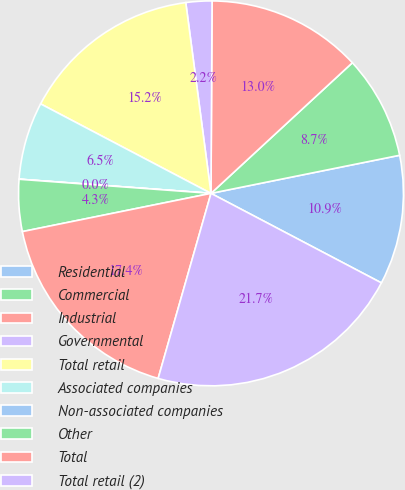Convert chart. <chart><loc_0><loc_0><loc_500><loc_500><pie_chart><fcel>Residential<fcel>Commercial<fcel>Industrial<fcel>Governmental<fcel>Total retail<fcel>Associated companies<fcel>Non-associated companies<fcel>Other<fcel>Total<fcel>Total retail (2)<nl><fcel>10.87%<fcel>8.7%<fcel>13.04%<fcel>2.18%<fcel>15.21%<fcel>6.52%<fcel>0.01%<fcel>4.35%<fcel>17.39%<fcel>21.73%<nl></chart> 